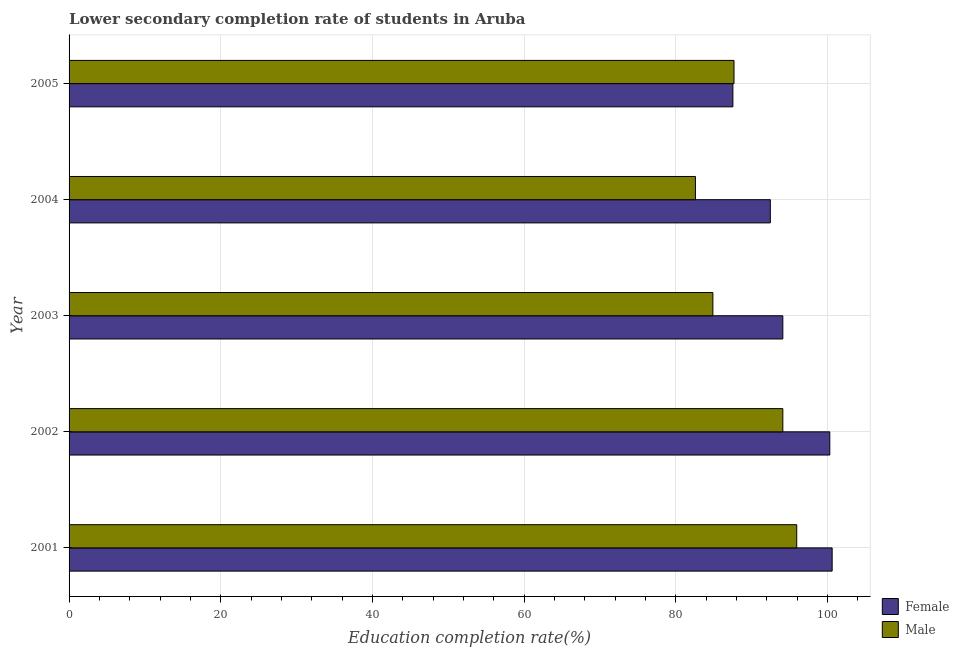How many different coloured bars are there?
Keep it short and to the point. 2. How many groups of bars are there?
Offer a terse response. 5. How many bars are there on the 3rd tick from the top?
Your response must be concise. 2. How many bars are there on the 5th tick from the bottom?
Offer a terse response. 2. In how many cases, is the number of bars for a given year not equal to the number of legend labels?
Provide a short and direct response. 0. What is the education completion rate of male students in 2003?
Your response must be concise. 84.88. Across all years, what is the maximum education completion rate of male students?
Keep it short and to the point. 95.93. Across all years, what is the minimum education completion rate of male students?
Provide a succinct answer. 82.58. In which year was the education completion rate of female students maximum?
Make the answer very short. 2001. In which year was the education completion rate of male students minimum?
Your answer should be compact. 2004. What is the total education completion rate of female students in the graph?
Ensure brevity in your answer.  474.97. What is the difference between the education completion rate of female students in 2001 and that in 2003?
Ensure brevity in your answer.  6.5. What is the difference between the education completion rate of female students in 2005 and the education completion rate of male students in 2001?
Provide a short and direct response. -8.42. What is the average education completion rate of male students per year?
Provide a succinct answer. 89.03. In the year 2004, what is the difference between the education completion rate of male students and education completion rate of female students?
Give a very brief answer. -9.87. In how many years, is the education completion rate of female students greater than 44 %?
Keep it short and to the point. 5. What is the ratio of the education completion rate of female students in 2002 to that in 2005?
Offer a terse response. 1.15. Is the education completion rate of male students in 2004 less than that in 2005?
Give a very brief answer. Yes. Is the difference between the education completion rate of female students in 2004 and 2005 greater than the difference between the education completion rate of male students in 2004 and 2005?
Make the answer very short. Yes. What is the difference between the highest and the second highest education completion rate of male students?
Provide a short and direct response. 1.83. What is the difference between the highest and the lowest education completion rate of female students?
Ensure brevity in your answer.  13.09. In how many years, is the education completion rate of male students greater than the average education completion rate of male students taken over all years?
Your answer should be very brief. 2. Is the sum of the education completion rate of female students in 2001 and 2003 greater than the maximum education completion rate of male students across all years?
Your answer should be very brief. Yes. What does the 1st bar from the top in 2003 represents?
Keep it short and to the point. Male. How many years are there in the graph?
Keep it short and to the point. 5. What is the difference between two consecutive major ticks on the X-axis?
Ensure brevity in your answer.  20. Are the values on the major ticks of X-axis written in scientific E-notation?
Your answer should be compact. No. Does the graph contain any zero values?
Your response must be concise. No. Does the graph contain grids?
Make the answer very short. Yes. Where does the legend appear in the graph?
Ensure brevity in your answer.  Bottom right. How many legend labels are there?
Provide a succinct answer. 2. How are the legend labels stacked?
Make the answer very short. Vertical. What is the title of the graph?
Provide a short and direct response. Lower secondary completion rate of students in Aruba. Does "From Government" appear as one of the legend labels in the graph?
Give a very brief answer. No. What is the label or title of the X-axis?
Make the answer very short. Education completion rate(%). What is the label or title of the Y-axis?
Make the answer very short. Year. What is the Education completion rate(%) of Female in 2001?
Your answer should be compact. 100.6. What is the Education completion rate(%) in Male in 2001?
Your answer should be very brief. 95.93. What is the Education completion rate(%) in Female in 2002?
Offer a terse response. 100.29. What is the Education completion rate(%) of Male in 2002?
Provide a succinct answer. 94.1. What is the Education completion rate(%) of Female in 2003?
Ensure brevity in your answer.  94.1. What is the Education completion rate(%) in Male in 2003?
Provide a short and direct response. 84.88. What is the Education completion rate(%) of Female in 2004?
Give a very brief answer. 92.45. What is the Education completion rate(%) in Male in 2004?
Provide a succinct answer. 82.58. What is the Education completion rate(%) in Female in 2005?
Provide a short and direct response. 87.52. What is the Education completion rate(%) of Male in 2005?
Provide a short and direct response. 87.67. Across all years, what is the maximum Education completion rate(%) in Female?
Ensure brevity in your answer.  100.6. Across all years, what is the maximum Education completion rate(%) of Male?
Make the answer very short. 95.93. Across all years, what is the minimum Education completion rate(%) of Female?
Offer a terse response. 87.52. Across all years, what is the minimum Education completion rate(%) of Male?
Keep it short and to the point. 82.58. What is the total Education completion rate(%) of Female in the graph?
Provide a short and direct response. 474.97. What is the total Education completion rate(%) of Male in the graph?
Your answer should be compact. 445.16. What is the difference between the Education completion rate(%) in Female in 2001 and that in 2002?
Ensure brevity in your answer.  0.31. What is the difference between the Education completion rate(%) in Male in 2001 and that in 2002?
Your response must be concise. 1.83. What is the difference between the Education completion rate(%) of Female in 2001 and that in 2003?
Your answer should be compact. 6.5. What is the difference between the Education completion rate(%) in Male in 2001 and that in 2003?
Your response must be concise. 11.05. What is the difference between the Education completion rate(%) of Female in 2001 and that in 2004?
Keep it short and to the point. 8.15. What is the difference between the Education completion rate(%) of Male in 2001 and that in 2004?
Your answer should be very brief. 13.35. What is the difference between the Education completion rate(%) in Female in 2001 and that in 2005?
Make the answer very short. 13.09. What is the difference between the Education completion rate(%) of Male in 2001 and that in 2005?
Ensure brevity in your answer.  8.27. What is the difference between the Education completion rate(%) of Female in 2002 and that in 2003?
Offer a terse response. 6.19. What is the difference between the Education completion rate(%) in Male in 2002 and that in 2003?
Your response must be concise. 9.22. What is the difference between the Education completion rate(%) in Female in 2002 and that in 2004?
Give a very brief answer. 7.84. What is the difference between the Education completion rate(%) in Male in 2002 and that in 2004?
Make the answer very short. 11.52. What is the difference between the Education completion rate(%) of Female in 2002 and that in 2005?
Your response must be concise. 12.78. What is the difference between the Education completion rate(%) of Male in 2002 and that in 2005?
Provide a succinct answer. 6.43. What is the difference between the Education completion rate(%) in Female in 2003 and that in 2004?
Give a very brief answer. 1.65. What is the difference between the Education completion rate(%) of Male in 2003 and that in 2004?
Provide a succinct answer. 2.3. What is the difference between the Education completion rate(%) in Female in 2003 and that in 2005?
Provide a short and direct response. 6.58. What is the difference between the Education completion rate(%) of Male in 2003 and that in 2005?
Offer a very short reply. -2.79. What is the difference between the Education completion rate(%) of Female in 2004 and that in 2005?
Offer a very short reply. 4.94. What is the difference between the Education completion rate(%) of Male in 2004 and that in 2005?
Ensure brevity in your answer.  -5.09. What is the difference between the Education completion rate(%) in Female in 2001 and the Education completion rate(%) in Male in 2002?
Provide a short and direct response. 6.5. What is the difference between the Education completion rate(%) in Female in 2001 and the Education completion rate(%) in Male in 2003?
Make the answer very short. 15.72. What is the difference between the Education completion rate(%) in Female in 2001 and the Education completion rate(%) in Male in 2004?
Ensure brevity in your answer.  18.02. What is the difference between the Education completion rate(%) of Female in 2001 and the Education completion rate(%) of Male in 2005?
Ensure brevity in your answer.  12.94. What is the difference between the Education completion rate(%) of Female in 2002 and the Education completion rate(%) of Male in 2003?
Offer a very short reply. 15.41. What is the difference between the Education completion rate(%) in Female in 2002 and the Education completion rate(%) in Male in 2004?
Your response must be concise. 17.71. What is the difference between the Education completion rate(%) of Female in 2002 and the Education completion rate(%) of Male in 2005?
Ensure brevity in your answer.  12.63. What is the difference between the Education completion rate(%) of Female in 2003 and the Education completion rate(%) of Male in 2004?
Offer a very short reply. 11.52. What is the difference between the Education completion rate(%) of Female in 2003 and the Education completion rate(%) of Male in 2005?
Give a very brief answer. 6.44. What is the difference between the Education completion rate(%) of Female in 2004 and the Education completion rate(%) of Male in 2005?
Your answer should be compact. 4.79. What is the average Education completion rate(%) in Female per year?
Your response must be concise. 94.99. What is the average Education completion rate(%) of Male per year?
Your answer should be compact. 89.03. In the year 2001, what is the difference between the Education completion rate(%) of Female and Education completion rate(%) of Male?
Your answer should be compact. 4.67. In the year 2002, what is the difference between the Education completion rate(%) of Female and Education completion rate(%) of Male?
Give a very brief answer. 6.19. In the year 2003, what is the difference between the Education completion rate(%) of Female and Education completion rate(%) of Male?
Your response must be concise. 9.22. In the year 2004, what is the difference between the Education completion rate(%) of Female and Education completion rate(%) of Male?
Your answer should be very brief. 9.87. In the year 2005, what is the difference between the Education completion rate(%) of Female and Education completion rate(%) of Male?
Your answer should be compact. -0.15. What is the ratio of the Education completion rate(%) in Female in 2001 to that in 2002?
Give a very brief answer. 1. What is the ratio of the Education completion rate(%) of Male in 2001 to that in 2002?
Your answer should be very brief. 1.02. What is the ratio of the Education completion rate(%) in Female in 2001 to that in 2003?
Provide a succinct answer. 1.07. What is the ratio of the Education completion rate(%) of Male in 2001 to that in 2003?
Offer a very short reply. 1.13. What is the ratio of the Education completion rate(%) in Female in 2001 to that in 2004?
Offer a very short reply. 1.09. What is the ratio of the Education completion rate(%) of Male in 2001 to that in 2004?
Make the answer very short. 1.16. What is the ratio of the Education completion rate(%) in Female in 2001 to that in 2005?
Provide a succinct answer. 1.15. What is the ratio of the Education completion rate(%) of Male in 2001 to that in 2005?
Your answer should be compact. 1.09. What is the ratio of the Education completion rate(%) of Female in 2002 to that in 2003?
Offer a very short reply. 1.07. What is the ratio of the Education completion rate(%) of Male in 2002 to that in 2003?
Your answer should be compact. 1.11. What is the ratio of the Education completion rate(%) in Female in 2002 to that in 2004?
Provide a short and direct response. 1.08. What is the ratio of the Education completion rate(%) in Male in 2002 to that in 2004?
Offer a very short reply. 1.14. What is the ratio of the Education completion rate(%) in Female in 2002 to that in 2005?
Provide a short and direct response. 1.15. What is the ratio of the Education completion rate(%) of Male in 2002 to that in 2005?
Make the answer very short. 1.07. What is the ratio of the Education completion rate(%) of Female in 2003 to that in 2004?
Offer a terse response. 1.02. What is the ratio of the Education completion rate(%) of Male in 2003 to that in 2004?
Your response must be concise. 1.03. What is the ratio of the Education completion rate(%) in Female in 2003 to that in 2005?
Offer a terse response. 1.08. What is the ratio of the Education completion rate(%) in Male in 2003 to that in 2005?
Give a very brief answer. 0.97. What is the ratio of the Education completion rate(%) of Female in 2004 to that in 2005?
Your answer should be compact. 1.06. What is the ratio of the Education completion rate(%) of Male in 2004 to that in 2005?
Provide a short and direct response. 0.94. What is the difference between the highest and the second highest Education completion rate(%) in Female?
Make the answer very short. 0.31. What is the difference between the highest and the second highest Education completion rate(%) of Male?
Make the answer very short. 1.83. What is the difference between the highest and the lowest Education completion rate(%) of Female?
Your response must be concise. 13.09. What is the difference between the highest and the lowest Education completion rate(%) in Male?
Offer a very short reply. 13.35. 